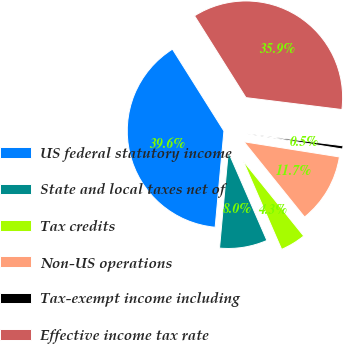Convert chart to OTSL. <chart><loc_0><loc_0><loc_500><loc_500><pie_chart><fcel>US federal statutory income<fcel>State and local taxes net of<fcel>Tax credits<fcel>Non-US operations<fcel>Tax-exempt income including<fcel>Effective income tax rate<nl><fcel>39.62%<fcel>7.98%<fcel>4.26%<fcel>11.7%<fcel>0.54%<fcel>35.9%<nl></chart> 